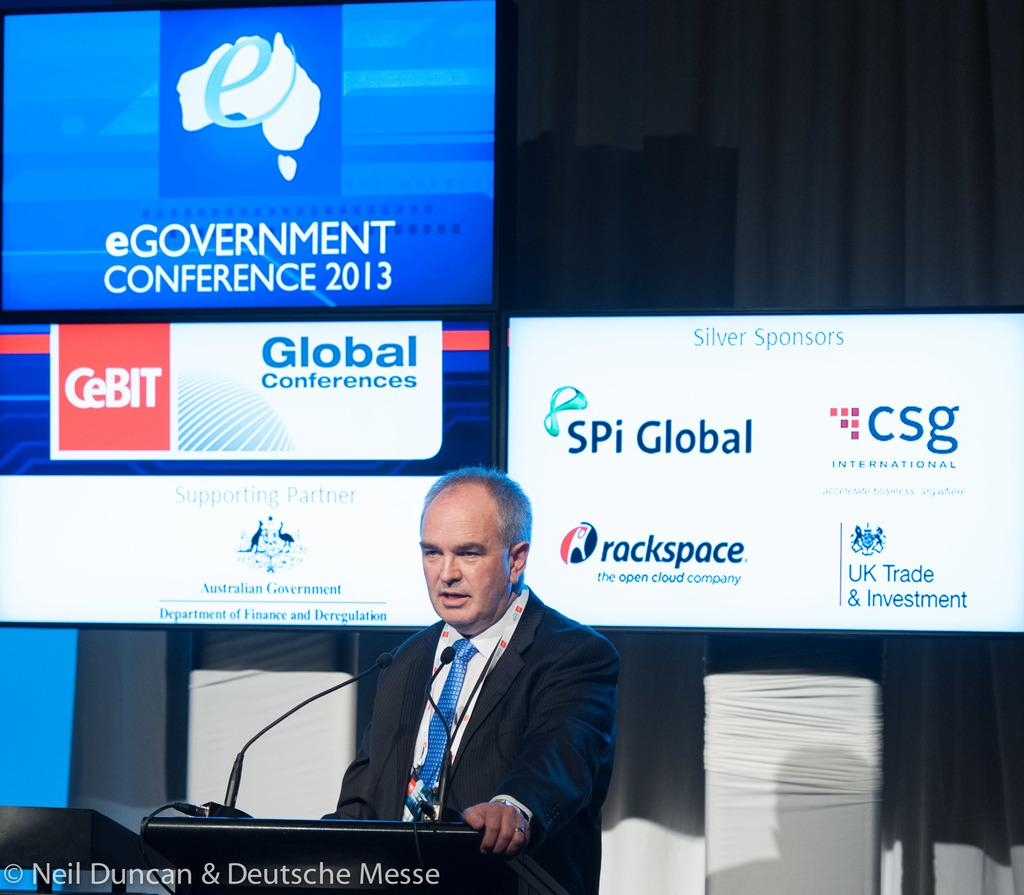<image>
Provide a brief description of the given image. A man with a blue tie is standing at a lecturn in front of a digital display of the eGovernment Conference 2013. 